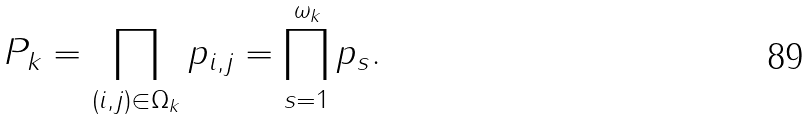Convert formula to latex. <formula><loc_0><loc_0><loc_500><loc_500>P _ { k } = \prod _ { ( i , j ) \in \Omega _ { k } } p _ { i , j } = \prod _ { s = 1 } ^ { \omega _ { k } } p _ { s } .</formula> 